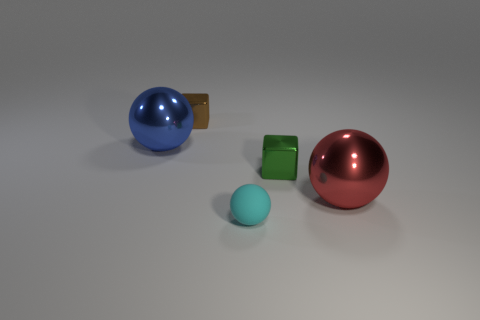Add 3 small brown metallic cubes. How many objects exist? 8 Subtract all metal spheres. How many spheres are left? 1 Subtract 1 balls. How many balls are left? 2 Subtract all yellow balls. Subtract all blue cubes. How many balls are left? 3 Subtract all yellow spheres. How many red blocks are left? 0 Subtract all tiny spheres. Subtract all small green objects. How many objects are left? 3 Add 2 metallic spheres. How many metallic spheres are left? 4 Add 4 metal things. How many metal things exist? 8 Subtract all green cubes. How many cubes are left? 1 Subtract 0 brown cylinders. How many objects are left? 5 